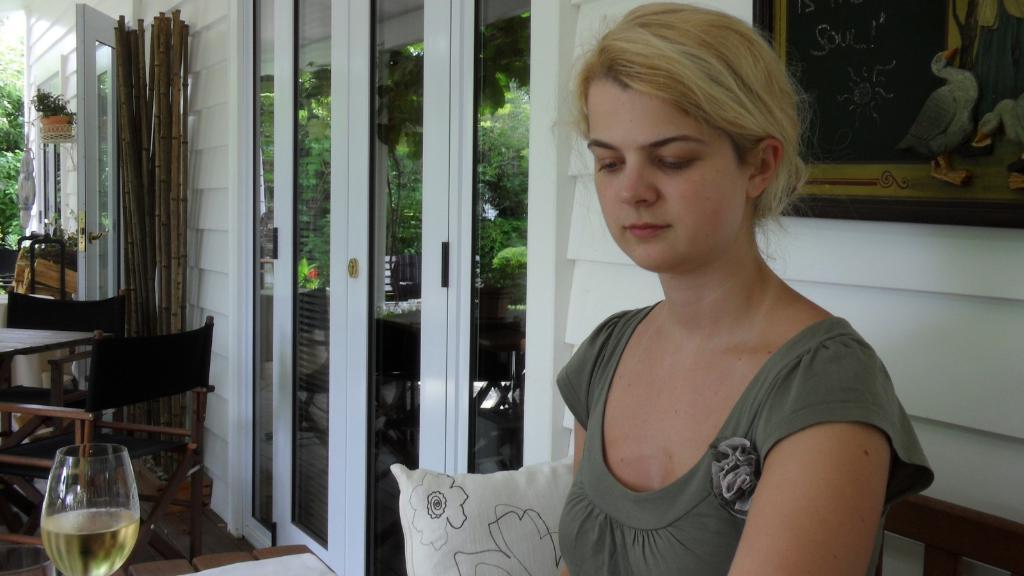In one or two sentences, can you explain what this image depicts? In this picture we can see a woman. This is table and these are the chairs. Here we can see a glass. On the background we can see a door and this is curtain. This is plant and these are the trees. 